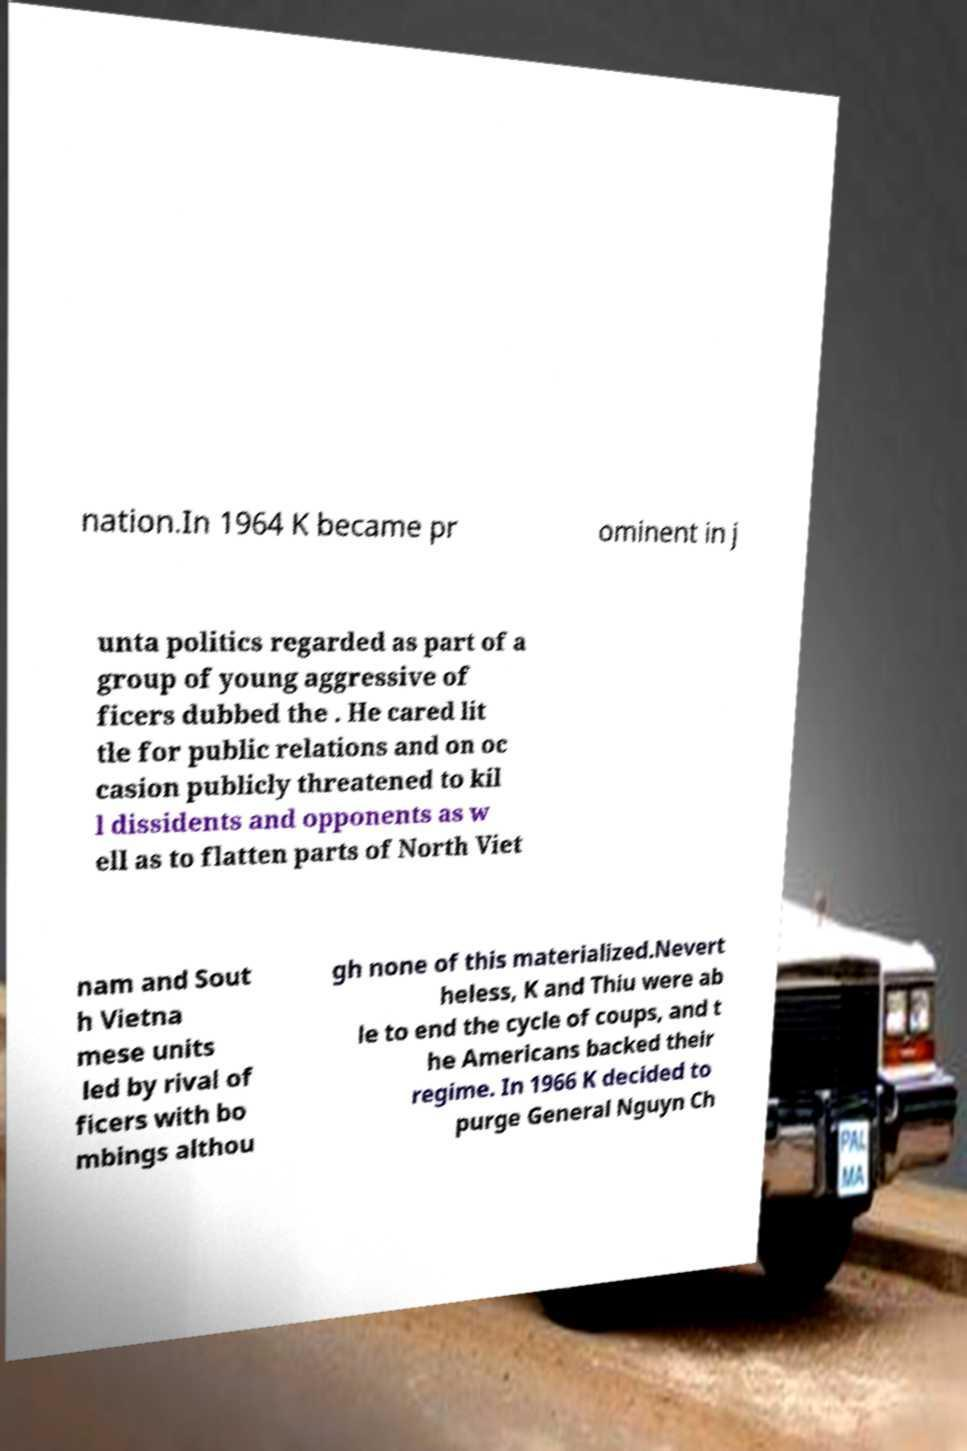Please read and relay the text visible in this image. What does it say? nation.In 1964 K became pr ominent in j unta politics regarded as part of a group of young aggressive of ficers dubbed the . He cared lit tle for public relations and on oc casion publicly threatened to kil l dissidents and opponents as w ell as to flatten parts of North Viet nam and Sout h Vietna mese units led by rival of ficers with bo mbings althou gh none of this materialized.Nevert heless, K and Thiu were ab le to end the cycle of coups, and t he Americans backed their regime. In 1966 K decided to purge General Nguyn Ch 